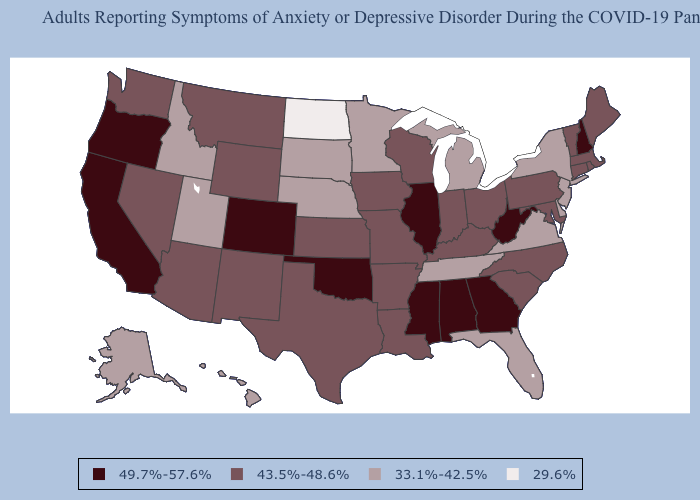What is the value of Arkansas?
Give a very brief answer. 43.5%-48.6%. Does Indiana have the same value as Arizona?
Answer briefly. Yes. Among the states that border New York , does New Jersey have the highest value?
Keep it brief. No. Which states hav the highest value in the MidWest?
Write a very short answer. Illinois. Does Maine have the highest value in the Northeast?
Short answer required. No. What is the highest value in the USA?
Quick response, please. 49.7%-57.6%. Name the states that have a value in the range 49.7%-57.6%?
Keep it brief. Alabama, California, Colorado, Georgia, Illinois, Mississippi, New Hampshire, Oklahoma, Oregon, West Virginia. What is the value of New Jersey?
Quick response, please. 33.1%-42.5%. What is the highest value in states that border South Dakota?
Quick response, please. 43.5%-48.6%. What is the value of Nebraska?
Quick response, please. 33.1%-42.5%. What is the value of Washington?
Concise answer only. 43.5%-48.6%. Among the states that border Ohio , does Michigan have the lowest value?
Be succinct. Yes. Name the states that have a value in the range 43.5%-48.6%?
Concise answer only. Arizona, Arkansas, Connecticut, Indiana, Iowa, Kansas, Kentucky, Louisiana, Maine, Maryland, Massachusetts, Missouri, Montana, Nevada, New Mexico, North Carolina, Ohio, Pennsylvania, Rhode Island, South Carolina, Texas, Vermont, Washington, Wisconsin, Wyoming. Does New Mexico have the highest value in the USA?
Concise answer only. No. 